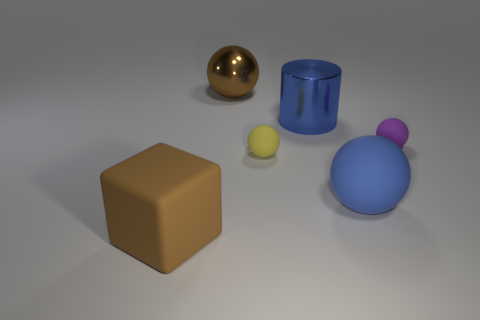What number of yellow objects are large rubber spheres or cylinders?
Provide a short and direct response. 0. Are there more small brown rubber spheres than large shiny cylinders?
Offer a very short reply. No. There is a brown object that is in front of the big blue matte object; is it the same size as the blue rubber sphere in front of the big metallic cylinder?
Your response must be concise. Yes. The sphere that is behind the small purple sphere that is on the right side of the tiny matte object left of the tiny purple ball is what color?
Your answer should be very brief. Brown. Is there a large rubber object that has the same shape as the small purple thing?
Offer a very short reply. Yes. Is the number of spheres that are in front of the purple sphere greater than the number of small yellow things?
Offer a terse response. Yes. How many shiny things are either small yellow blocks or spheres?
Make the answer very short. 1. There is a matte object that is both to the right of the brown block and to the left of the blue rubber thing; what size is it?
Your response must be concise. Small. Are there any tiny things to the left of the blue object that is behind the big rubber sphere?
Keep it short and to the point. Yes. There is a tiny purple object; what number of tiny balls are in front of it?
Offer a very short reply. 1. 